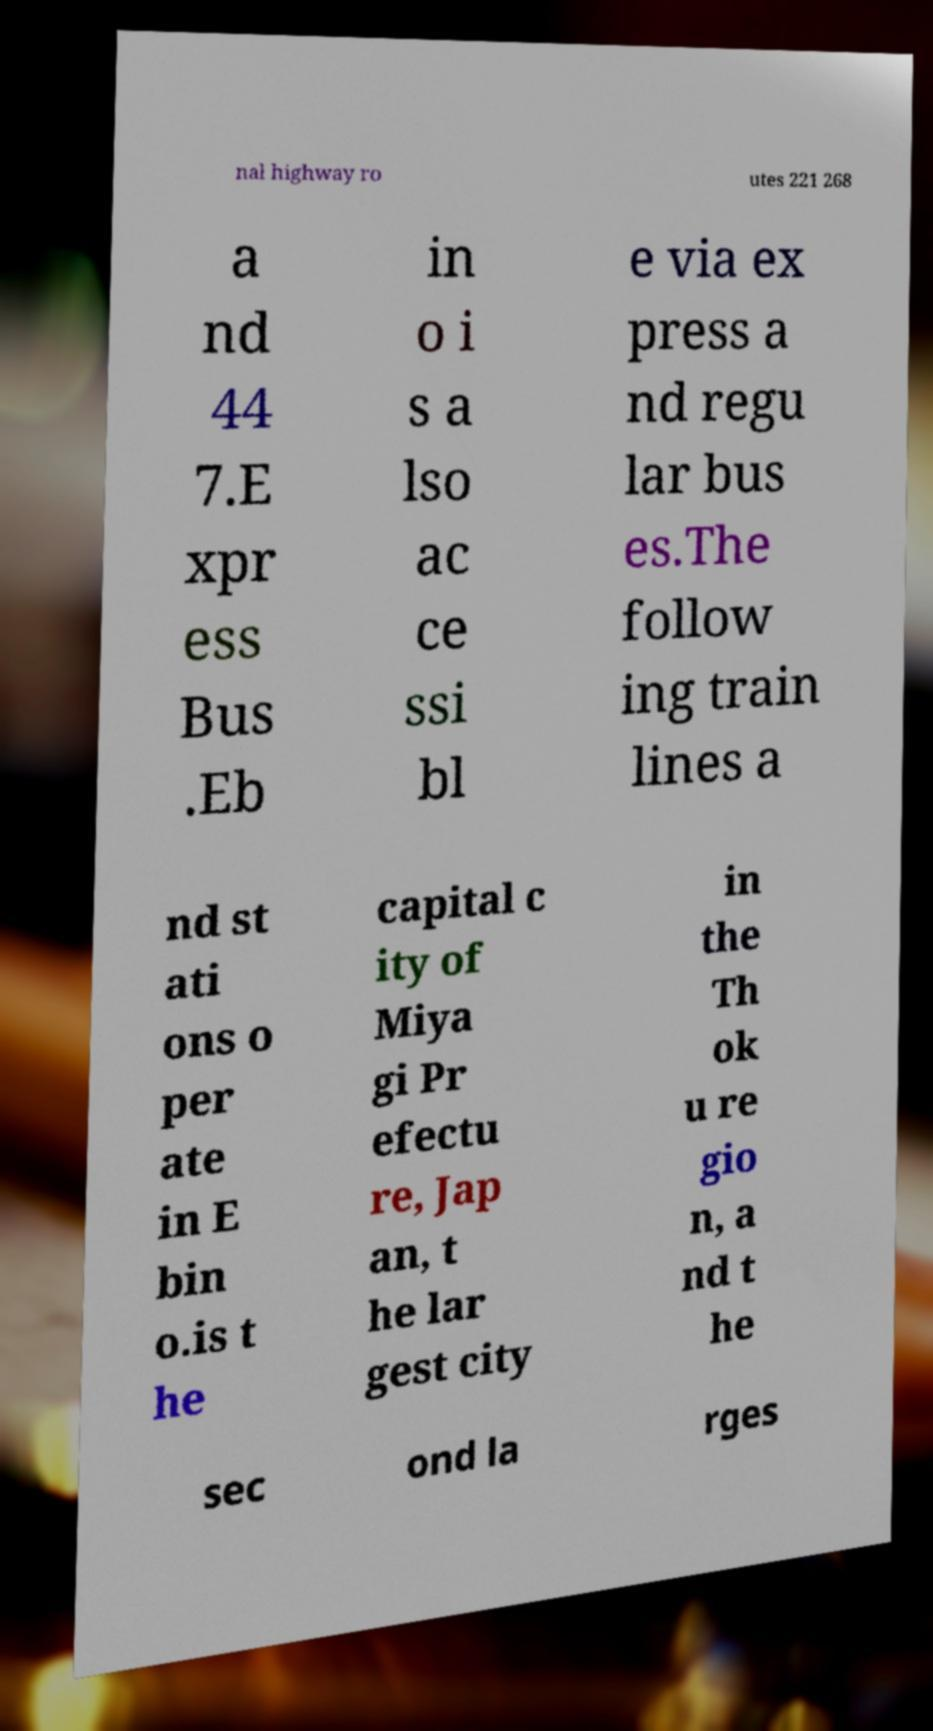Could you extract and type out the text from this image? nal highway ro utes 221 268 a nd 44 7.E xpr ess Bus .Eb in o i s a lso ac ce ssi bl e via ex press a nd regu lar bus es.The follow ing train lines a nd st ati ons o per ate in E bin o.is t he capital c ity of Miya gi Pr efectu re, Jap an, t he lar gest city in the Th ok u re gio n, a nd t he sec ond la rges 